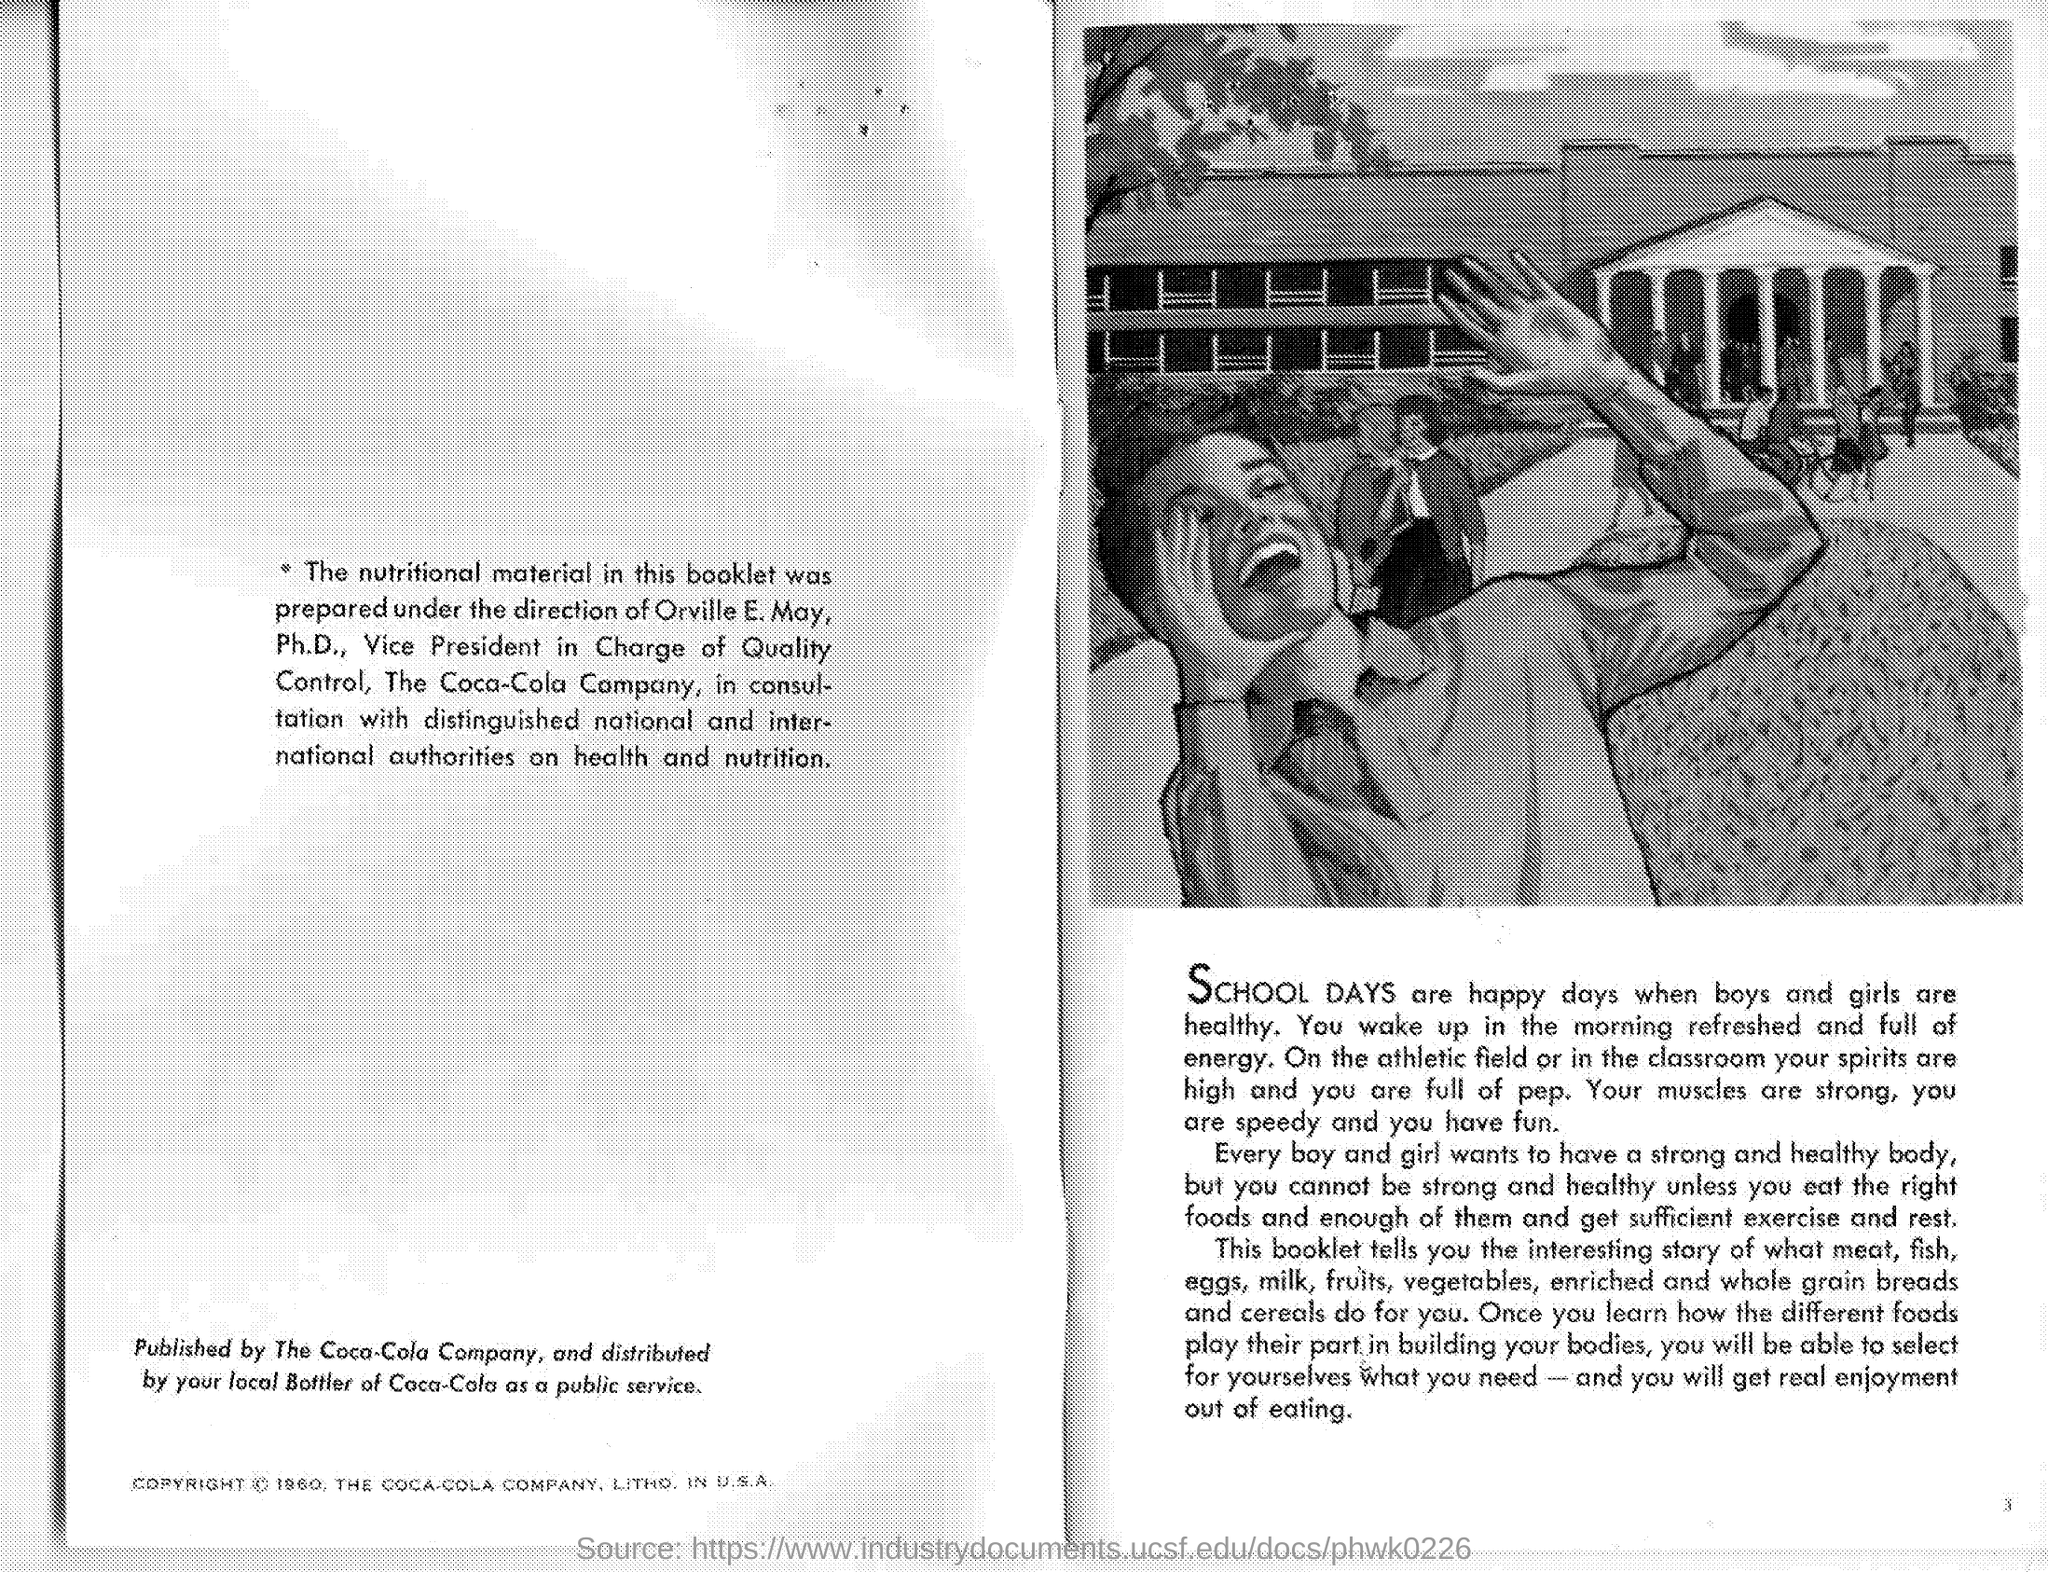The Nutritional material in this booklet was prepared under whose direction?
Your answer should be compact. Orville E. May. Which company does he work for?
Ensure brevity in your answer.  The Coca-Cola Company. 